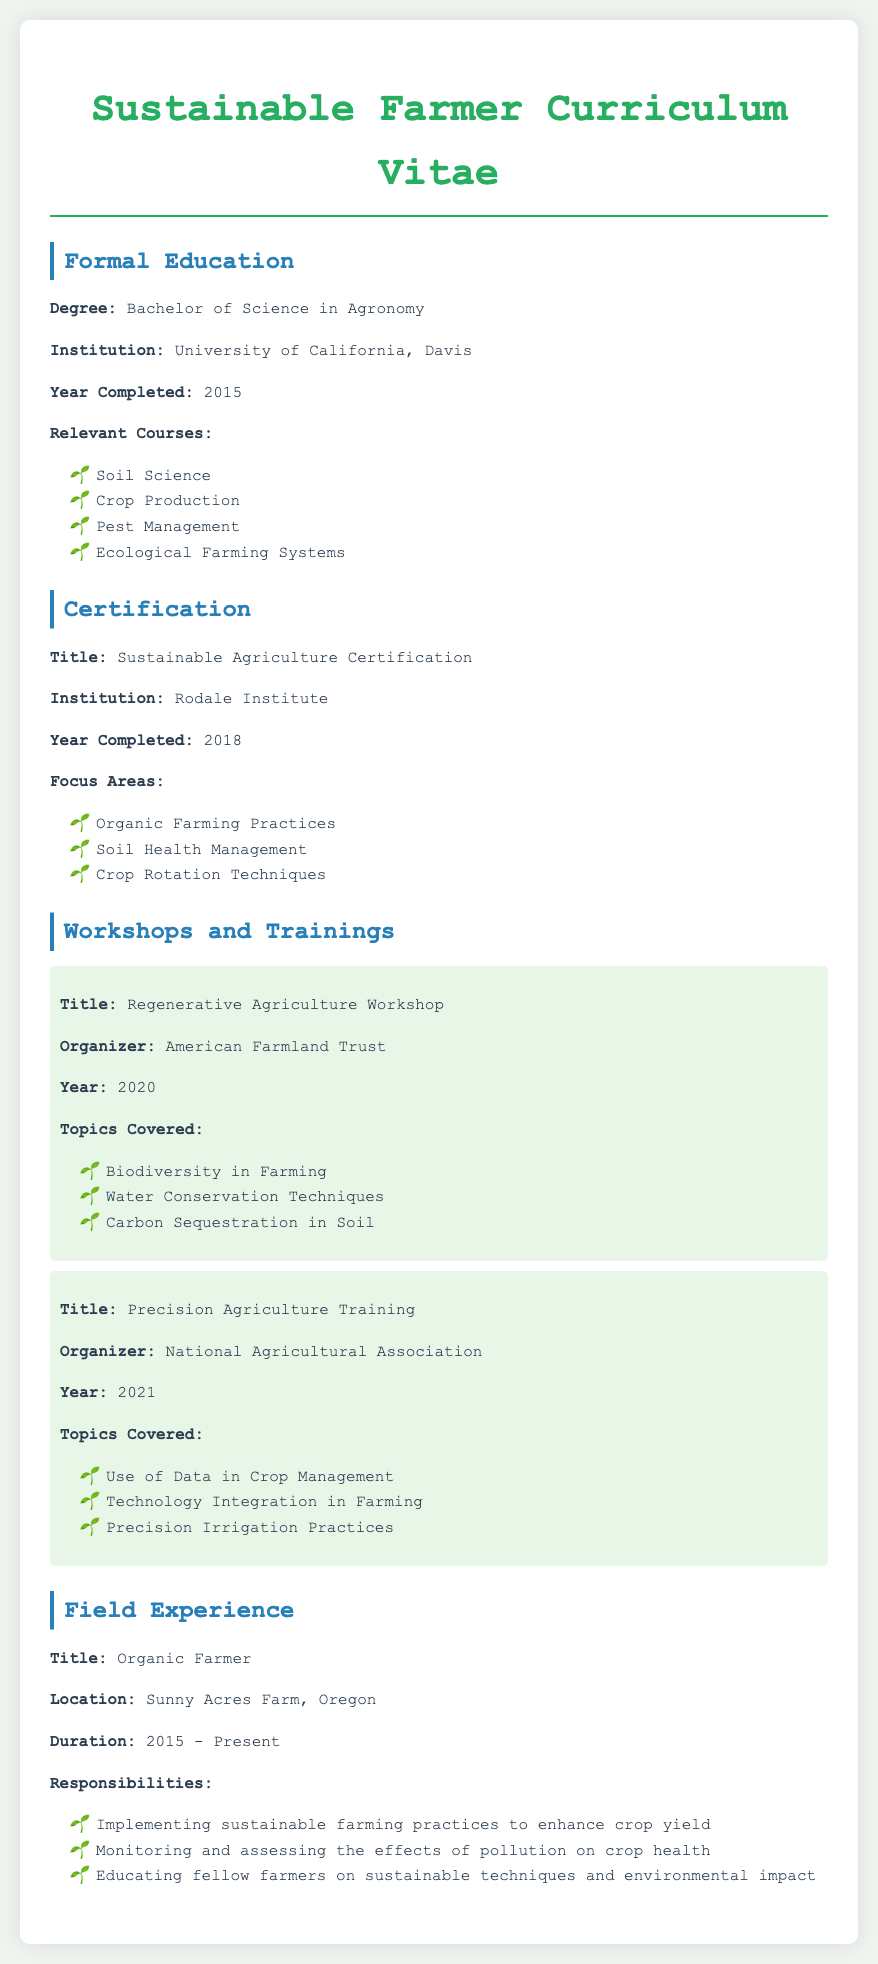What degree does the individual hold? The document states that the individual has a Bachelor of Science in Agronomy.
Answer: Bachelor of Science in Agronomy Which institution awarded the Sustainable Agriculture Certification? The document lists that the Sustainable Agriculture Certification was awarded by the Rodale Institute.
Answer: Rodale Institute In what year did the individual complete their Bachelor's degree? The document indicates that the Bachelor's degree was completed in 2015.
Answer: 2015 What was one focus area of the Sustainable Agriculture Certification? The document provides "Soil Health Management" as one of the focus areas listed under the certification.
Answer: Soil Health Management Which workshop was organized by the American Farmland Trust? According to the document, the Regenerative Agriculture Workshop was organized by the American Farmland Trust.
Answer: Regenerative Agriculture Workshop What experience does the individual have in the field of sustainable farming? The document describes their role as an Organic Farmer implementing sustainable practices and educating others.
Answer: Organic Farmer What year was the Precision Agriculture Training completed? The document states that this training was completed in 2021.
Answer: 2021 How long has the individual been working at Sunny Acres Farm? The document indicates that the duration of work at Sunny Acres Farm is from 2015 to present.
Answer: 2015 - Present What type of farming practices did the individual focus on during their training? The document lists "Organic Farming Practices" as a key focus during the Sustainable Agriculture Certification.
Answer: Organic Farming Practices 